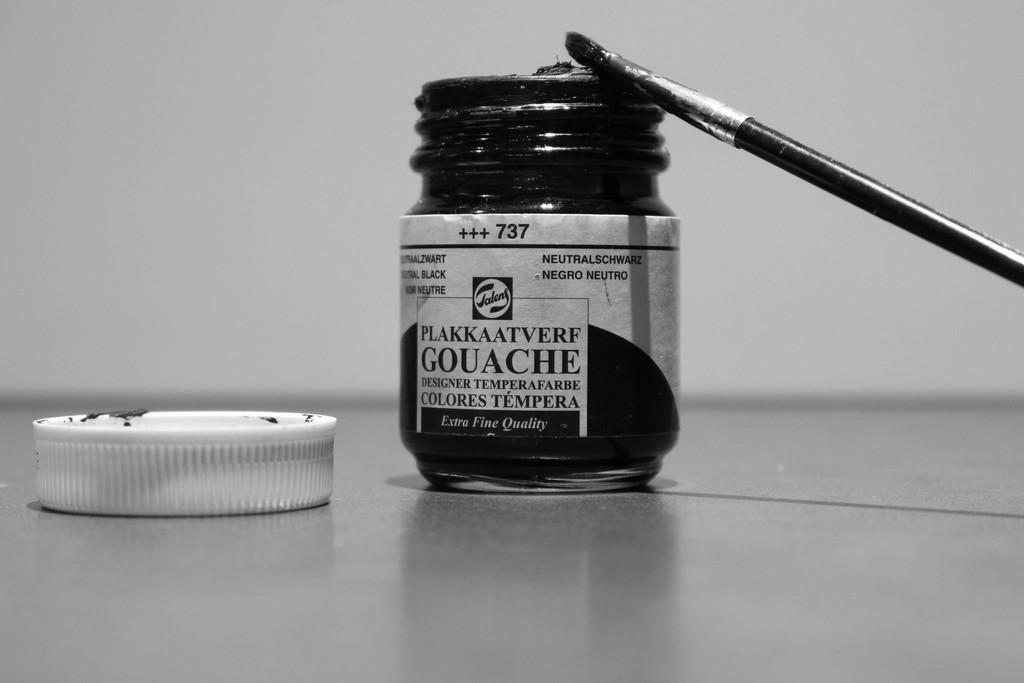<image>
Render a clear and concise summary of the photo. A jar of Plakkaatverf Gouache is open with the lid next to it. 